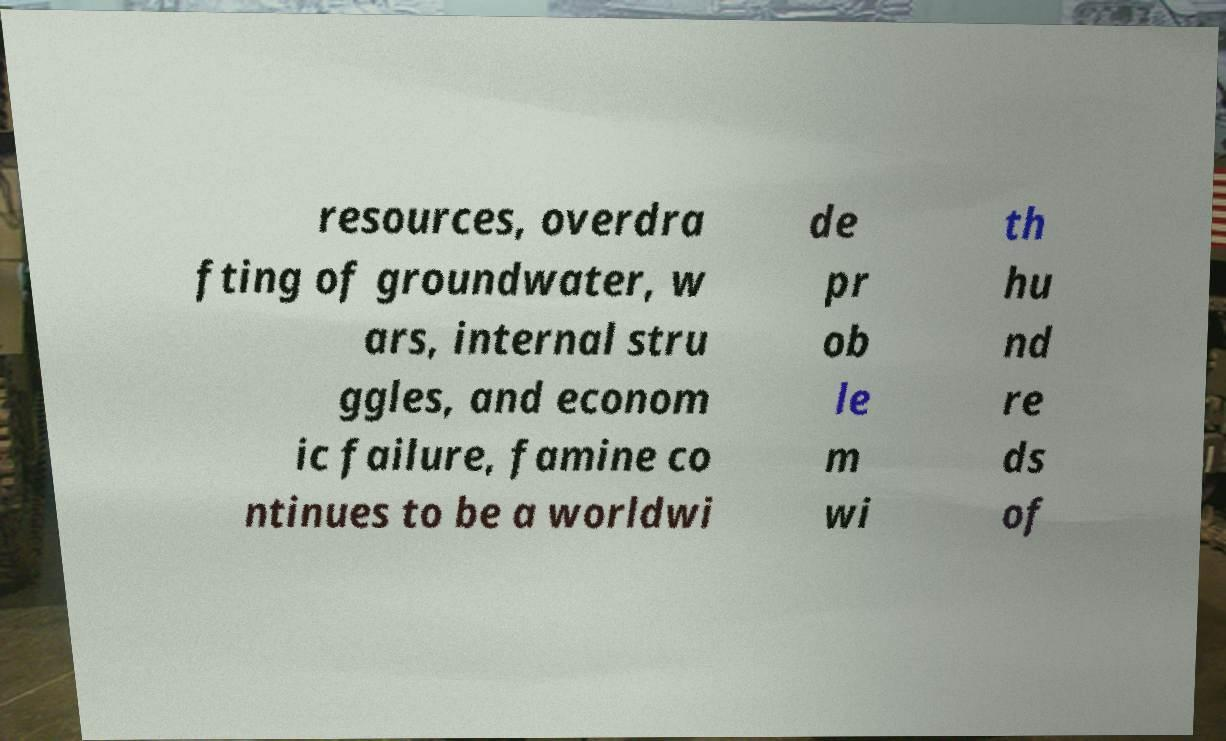What messages or text are displayed in this image? I need them in a readable, typed format. resources, overdra fting of groundwater, w ars, internal stru ggles, and econom ic failure, famine co ntinues to be a worldwi de pr ob le m wi th hu nd re ds of 